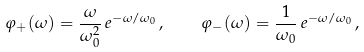<formula> <loc_0><loc_0><loc_500><loc_500>\varphi _ { + } ( \omega ) = \frac { \omega } { \omega _ { 0 } ^ { 2 } } \, e ^ { - \omega / \omega _ { 0 } } \, , \quad \varphi _ { - } ( \omega ) = \frac { 1 } { \omega _ { 0 } } \, e ^ { - \omega / \omega _ { 0 } } \, ,</formula> 